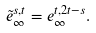Convert formula to latex. <formula><loc_0><loc_0><loc_500><loc_500>\tilde { e } _ { \infty } ^ { s , t } = e _ { \infty } ^ { t , 2 t - s } .</formula> 